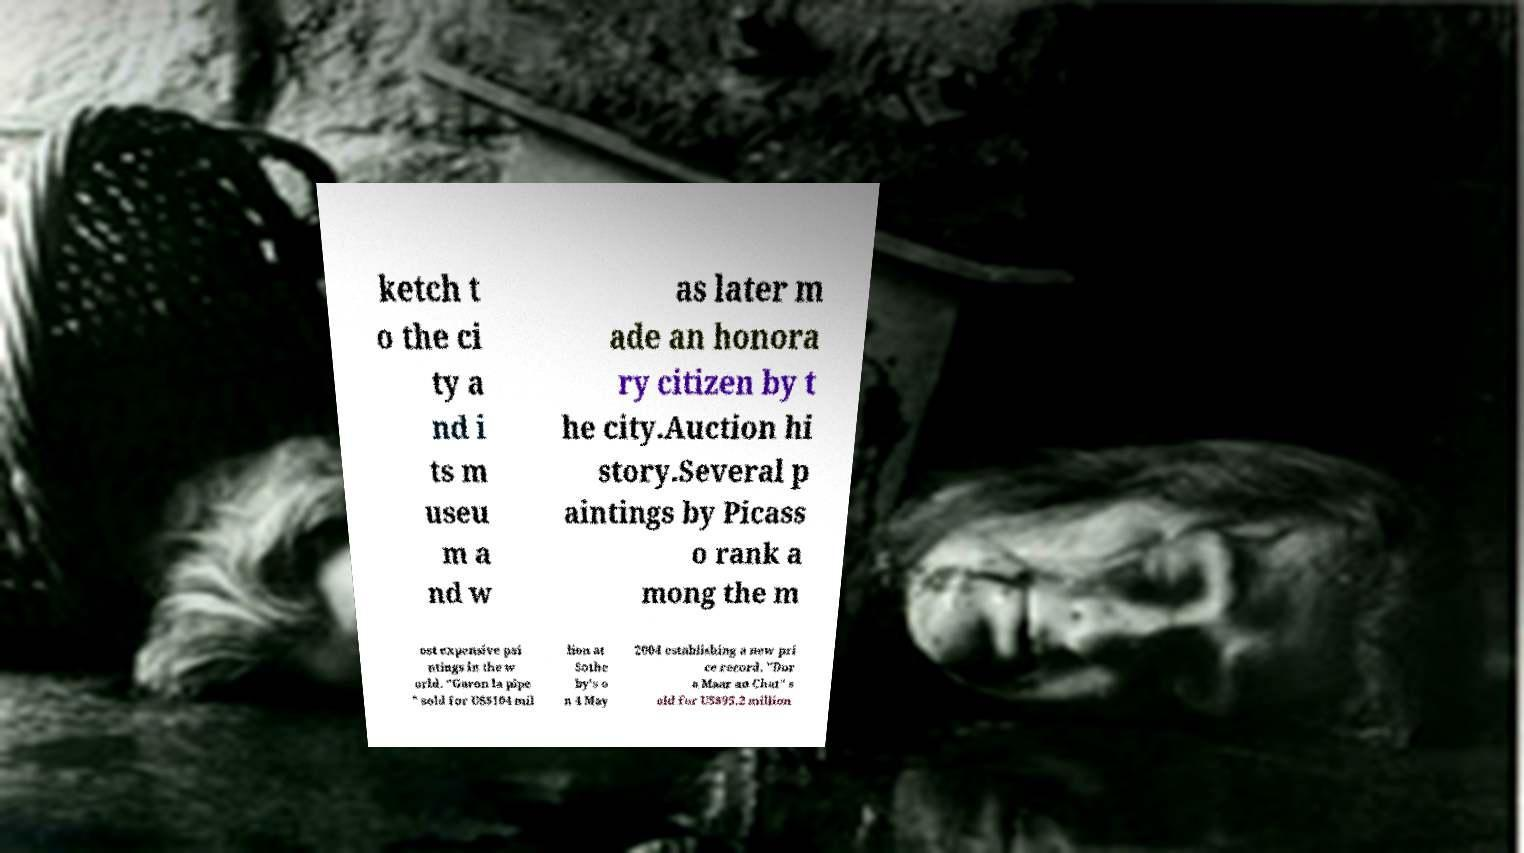Please identify and transcribe the text found in this image. ketch t o the ci ty a nd i ts m useu m a nd w as later m ade an honora ry citizen by t he city.Auction hi story.Several p aintings by Picass o rank a mong the m ost expensive pai ntings in the w orld. "Garon la pipe " sold for US$104 mil lion at Sothe by's o n 4 May 2004 establishing a new pri ce record. "Dor a Maar au Chat" s old for US$95.2 million 